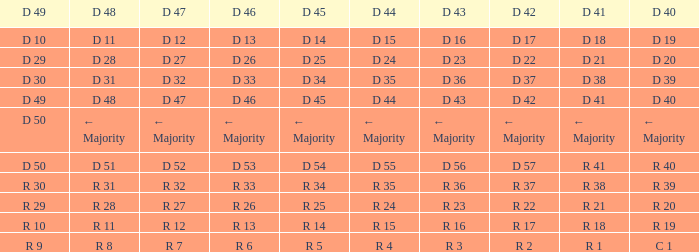I request the d 45 and d 42 of r 22 R 25. 